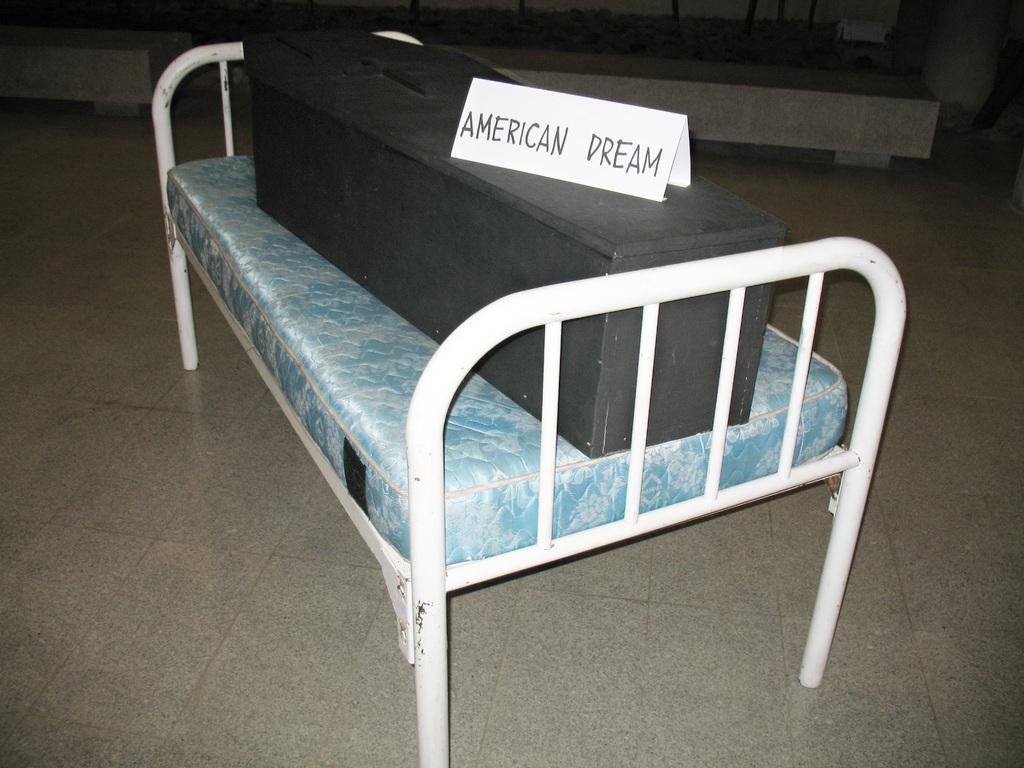Please provide a concise description of this image. Here there is a box on the bed which is on the floor and there is a text written on a paper on the box. 